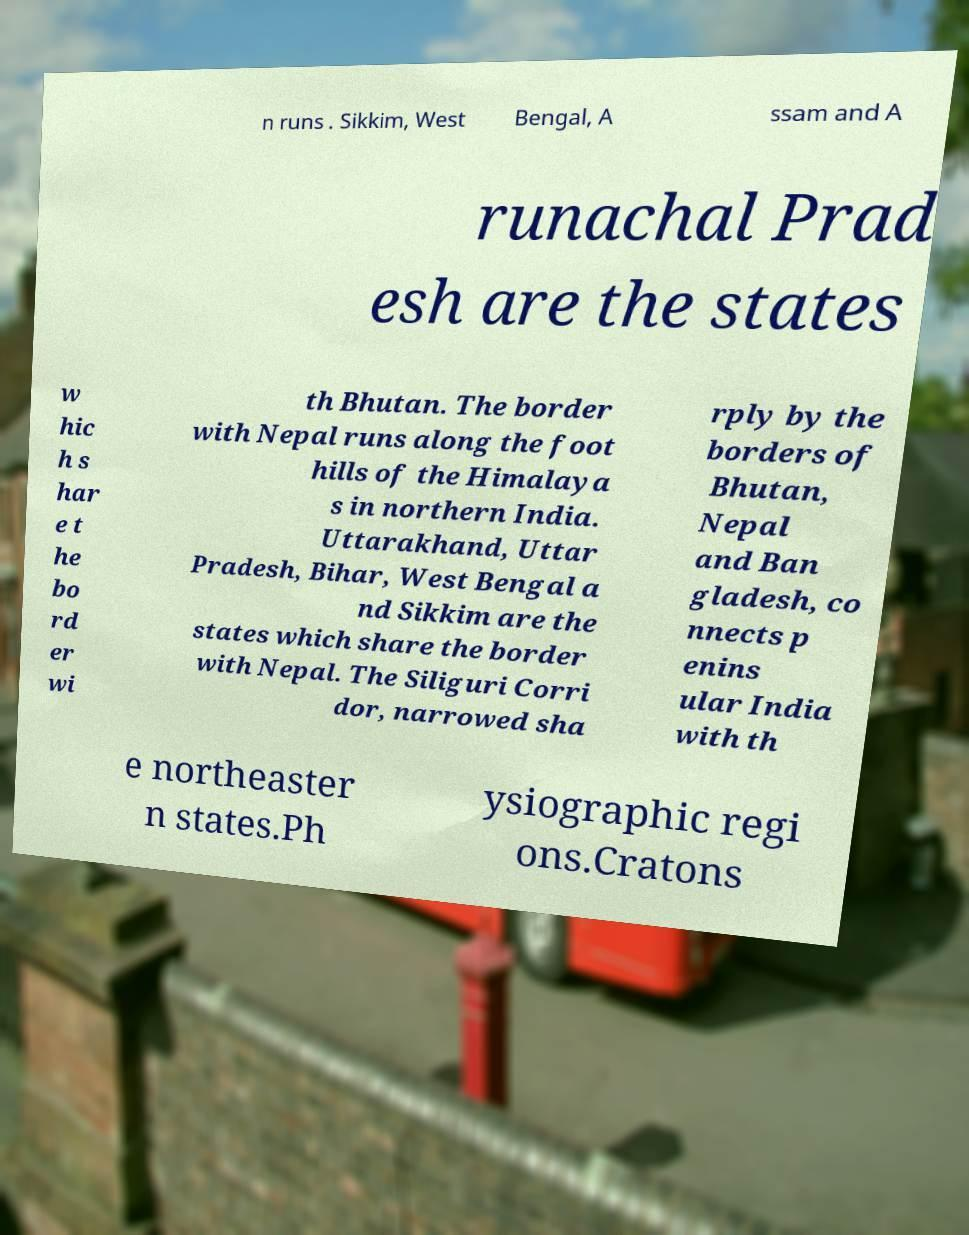Can you read and provide the text displayed in the image?This photo seems to have some interesting text. Can you extract and type it out for me? n runs . Sikkim, West Bengal, A ssam and A runachal Prad esh are the states w hic h s har e t he bo rd er wi th Bhutan. The border with Nepal runs along the foot hills of the Himalaya s in northern India. Uttarakhand, Uttar Pradesh, Bihar, West Bengal a nd Sikkim are the states which share the border with Nepal. The Siliguri Corri dor, narrowed sha rply by the borders of Bhutan, Nepal and Ban gladesh, co nnects p enins ular India with th e northeaster n states.Ph ysiographic regi ons.Cratons 